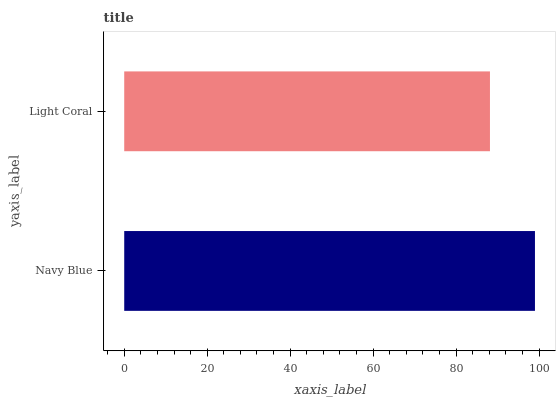Is Light Coral the minimum?
Answer yes or no. Yes. Is Navy Blue the maximum?
Answer yes or no. Yes. Is Light Coral the maximum?
Answer yes or no. No. Is Navy Blue greater than Light Coral?
Answer yes or no. Yes. Is Light Coral less than Navy Blue?
Answer yes or no. Yes. Is Light Coral greater than Navy Blue?
Answer yes or no. No. Is Navy Blue less than Light Coral?
Answer yes or no. No. Is Navy Blue the high median?
Answer yes or no. Yes. Is Light Coral the low median?
Answer yes or no. Yes. Is Light Coral the high median?
Answer yes or no. No. Is Navy Blue the low median?
Answer yes or no. No. 